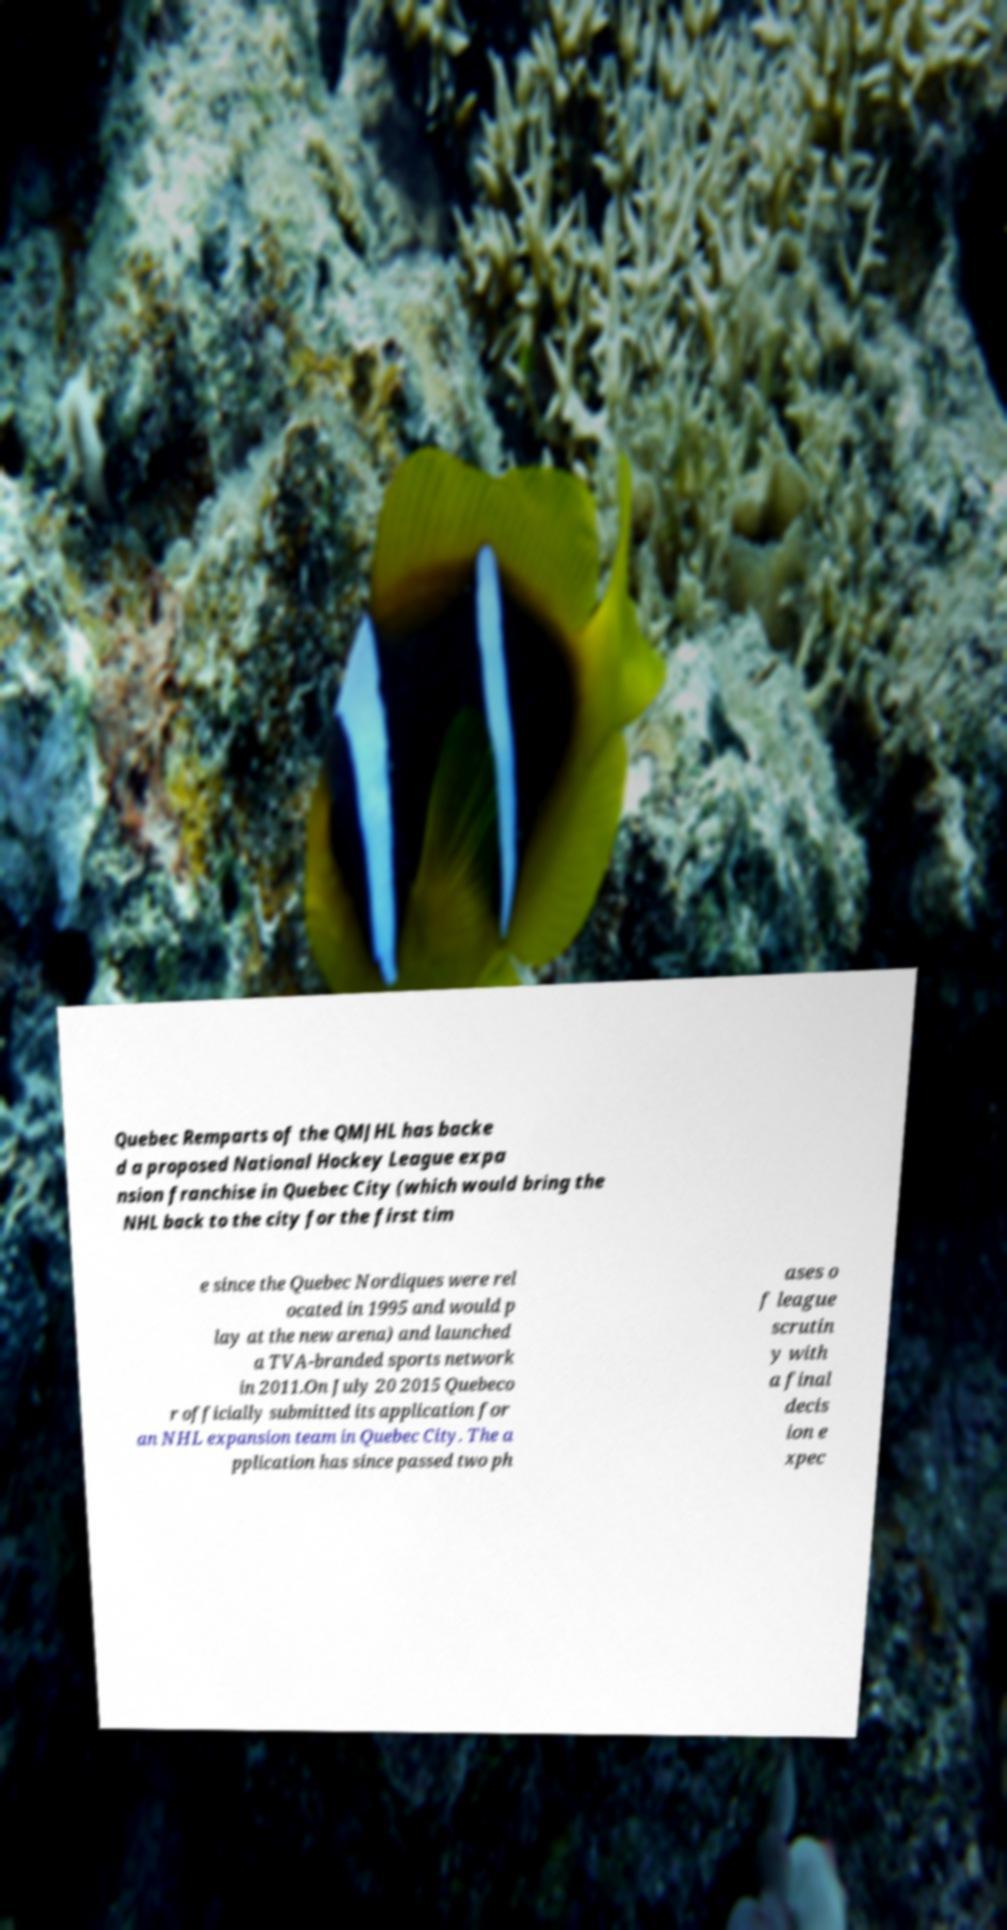Can you accurately transcribe the text from the provided image for me? Quebec Remparts of the QMJHL has backe d a proposed National Hockey League expa nsion franchise in Quebec City (which would bring the NHL back to the city for the first tim e since the Quebec Nordiques were rel ocated in 1995 and would p lay at the new arena) and launched a TVA-branded sports network in 2011.On July 20 2015 Quebeco r officially submitted its application for an NHL expansion team in Quebec City. The a pplication has since passed two ph ases o f league scrutin y with a final decis ion e xpec 